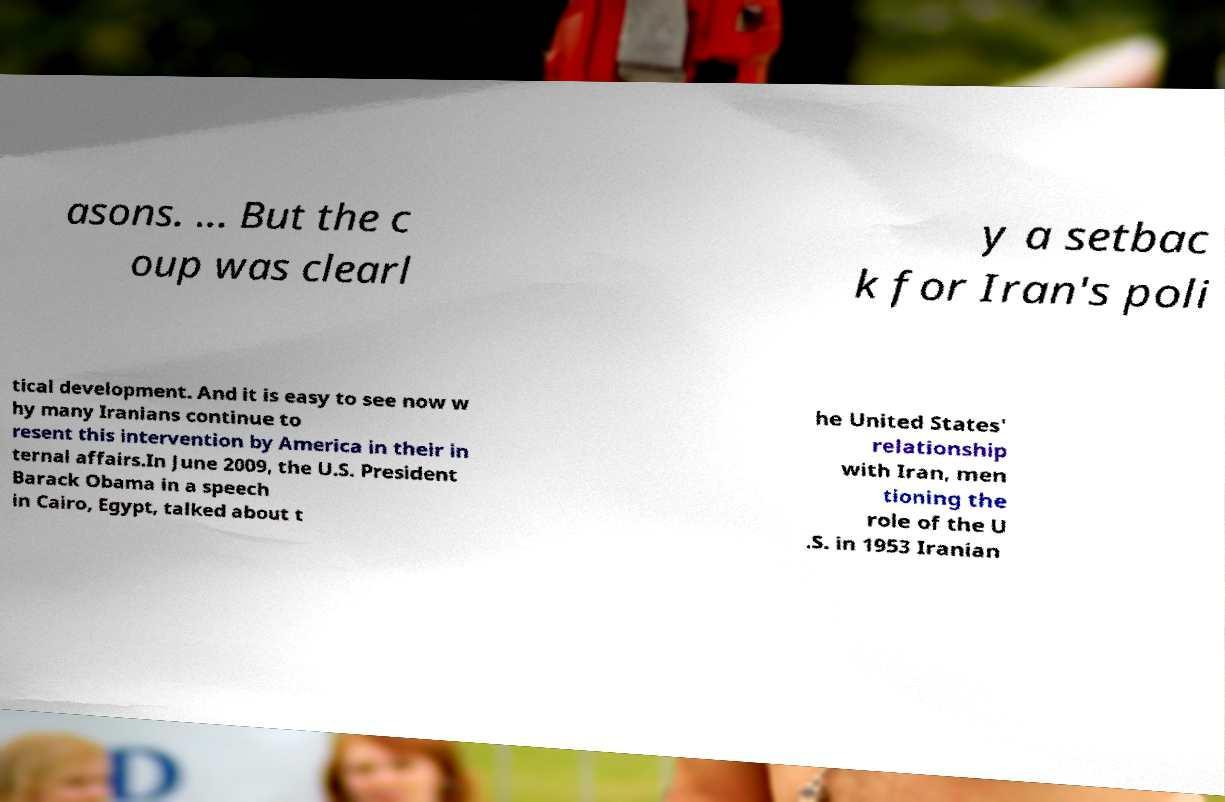Could you assist in decoding the text presented in this image and type it out clearly? asons. ... But the c oup was clearl y a setbac k for Iran's poli tical development. And it is easy to see now w hy many Iranians continue to resent this intervention by America in their in ternal affairs.In June 2009, the U.S. President Barack Obama in a speech in Cairo, Egypt, talked about t he United States' relationship with Iran, men tioning the role of the U .S. in 1953 Iranian 